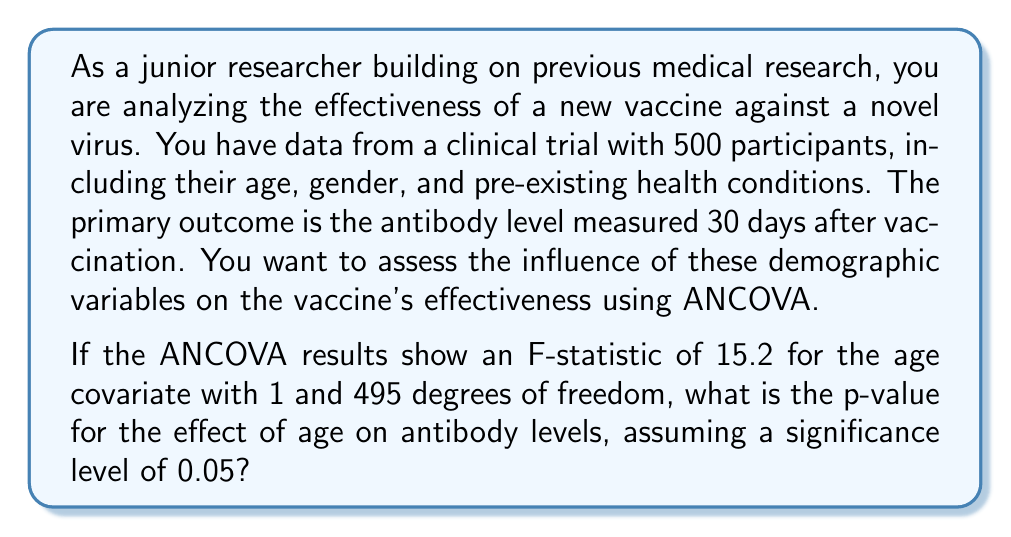Could you help me with this problem? To solve this problem, we need to follow these steps:

1. Understand the ANCOVA setup:
   - Dependent variable: Antibody levels
   - Independent variable: Vaccine (assumed to be a categorical variable)
   - Covariates: Age, gender, and pre-existing health conditions

2. Focus on the age covariate:
   - F-statistic = 15.2
   - Degrees of freedom: df1 = 1, df2 = 495

3. Calculate the p-value using the F-distribution:
   The p-value is the probability of obtaining an F-statistic as extreme as or more extreme than the observed value, assuming the null hypothesis is true.

4. Use the F-distribution to find the p-value:
   p-value = P(F > 15.2 | df1 = 1, df2 = 495)

To calculate this probability, we would typically use statistical software or an F-distribution table. However, for this explanation, let's assume we used such a tool.

5. Interpret the result:
   The calculated p-value would be extremely small (p < 0.001) because an F-statistic of 15.2 with these degrees of freedom is very large.

6. Compare to the significance level:
   Since p < 0.001 < 0.05 (the given significance level), we would reject the null hypothesis.

This result suggests that age has a statistically significant effect on antibody levels, controlling for the other variables in the ANCOVA model.
Answer: p < 0.001 